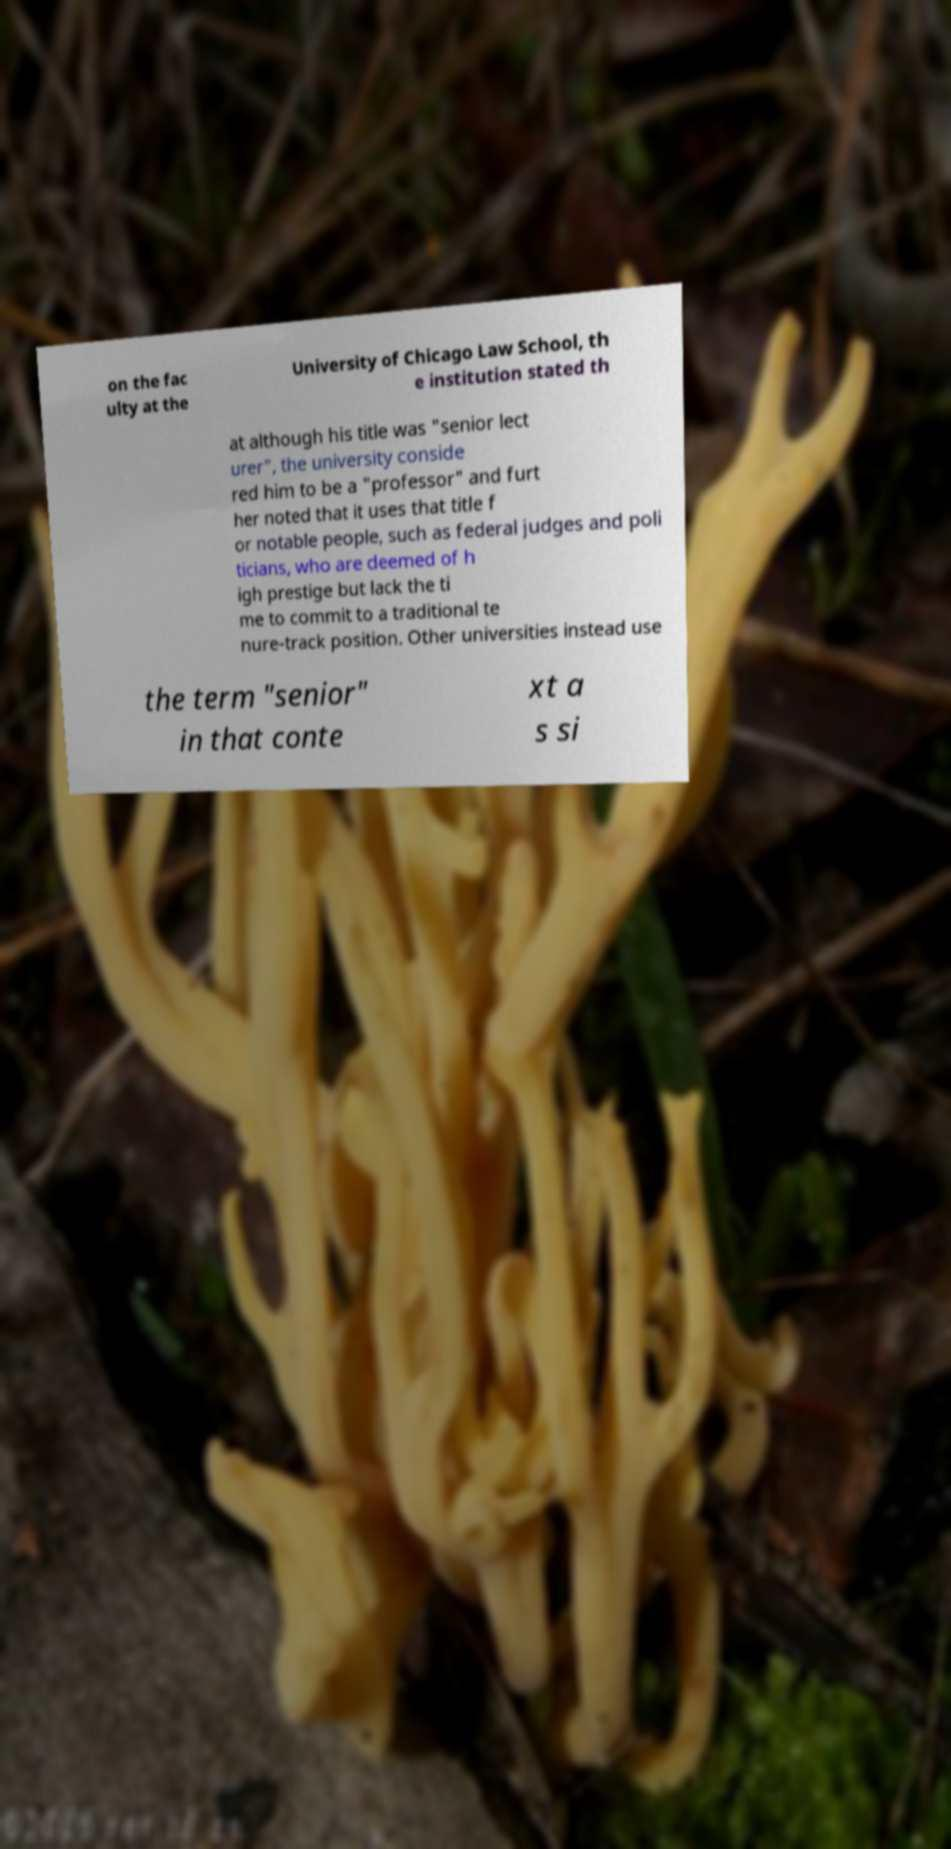Can you accurately transcribe the text from the provided image for me? on the fac ulty at the University of Chicago Law School, th e institution stated th at although his title was "senior lect urer", the university conside red him to be a "professor" and furt her noted that it uses that title f or notable people, such as federal judges and poli ticians, who are deemed of h igh prestige but lack the ti me to commit to a traditional te nure-track position. Other universities instead use the term "senior" in that conte xt a s si 